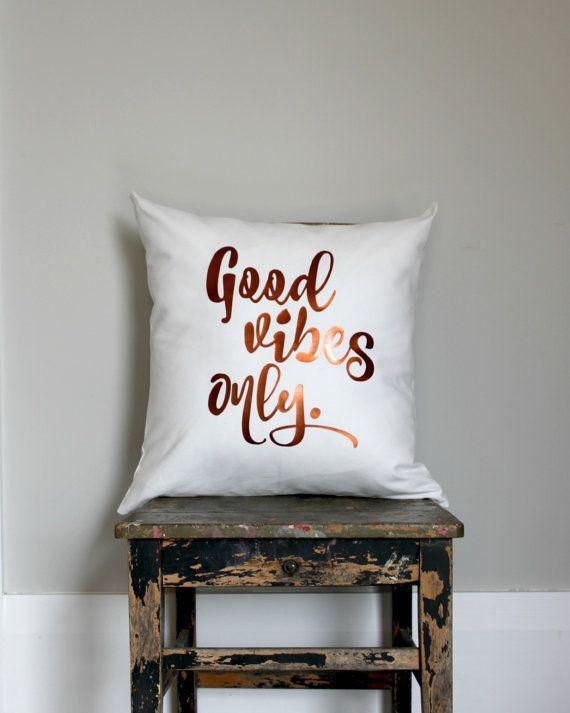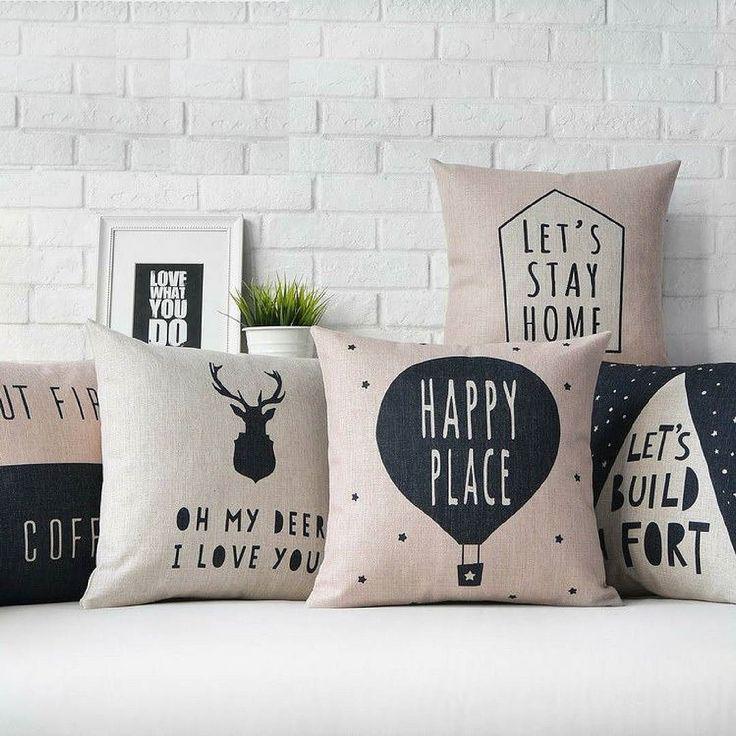The first image is the image on the left, the second image is the image on the right. Examine the images to the left and right. Is the description "The left image includes a text-printed square pillow on a square wood stand, and the right image includes a pillow with a mammal depicted on it." accurate? Answer yes or no. Yes. The first image is the image on the left, the second image is the image on the right. For the images shown, is this caption "All of the pillows are printed with a novelty design." true? Answer yes or no. Yes. 